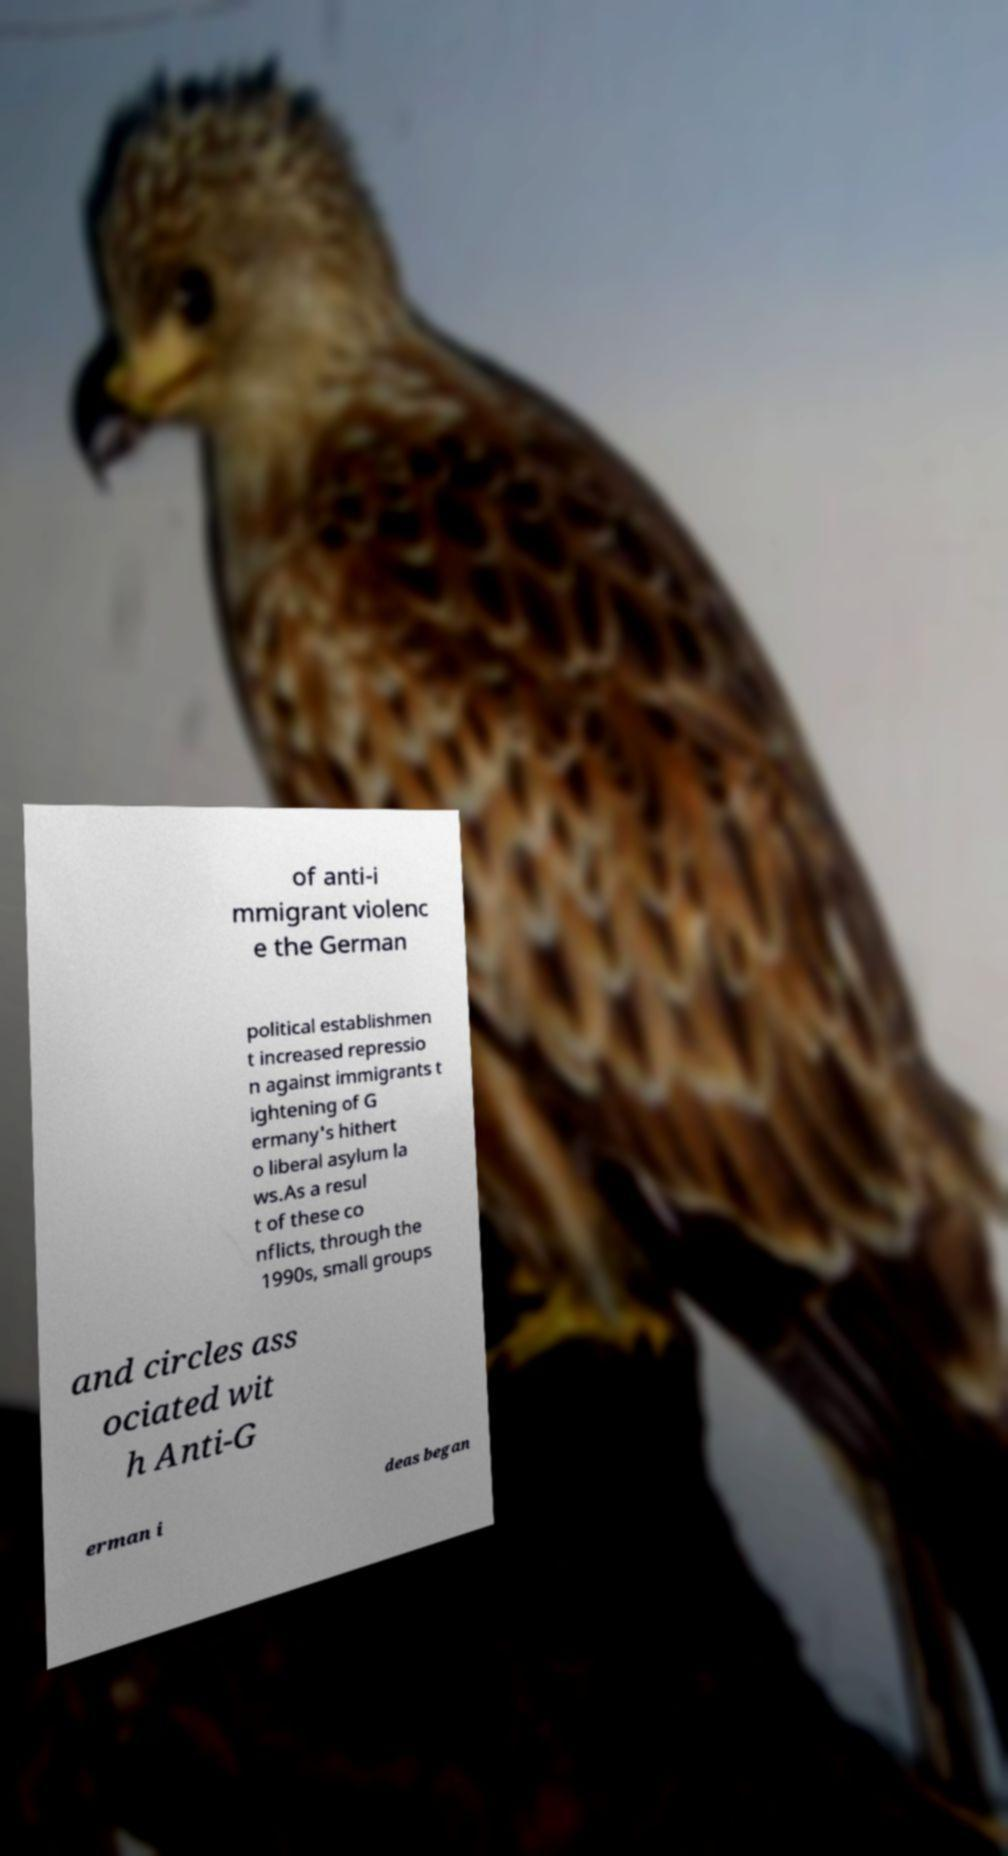I need the written content from this picture converted into text. Can you do that? of anti-i mmigrant violenc e the German political establishmen t increased repressio n against immigrants t ightening of G ermany's hithert o liberal asylum la ws.As a resul t of these co nflicts, through the 1990s, small groups and circles ass ociated wit h Anti-G erman i deas began 